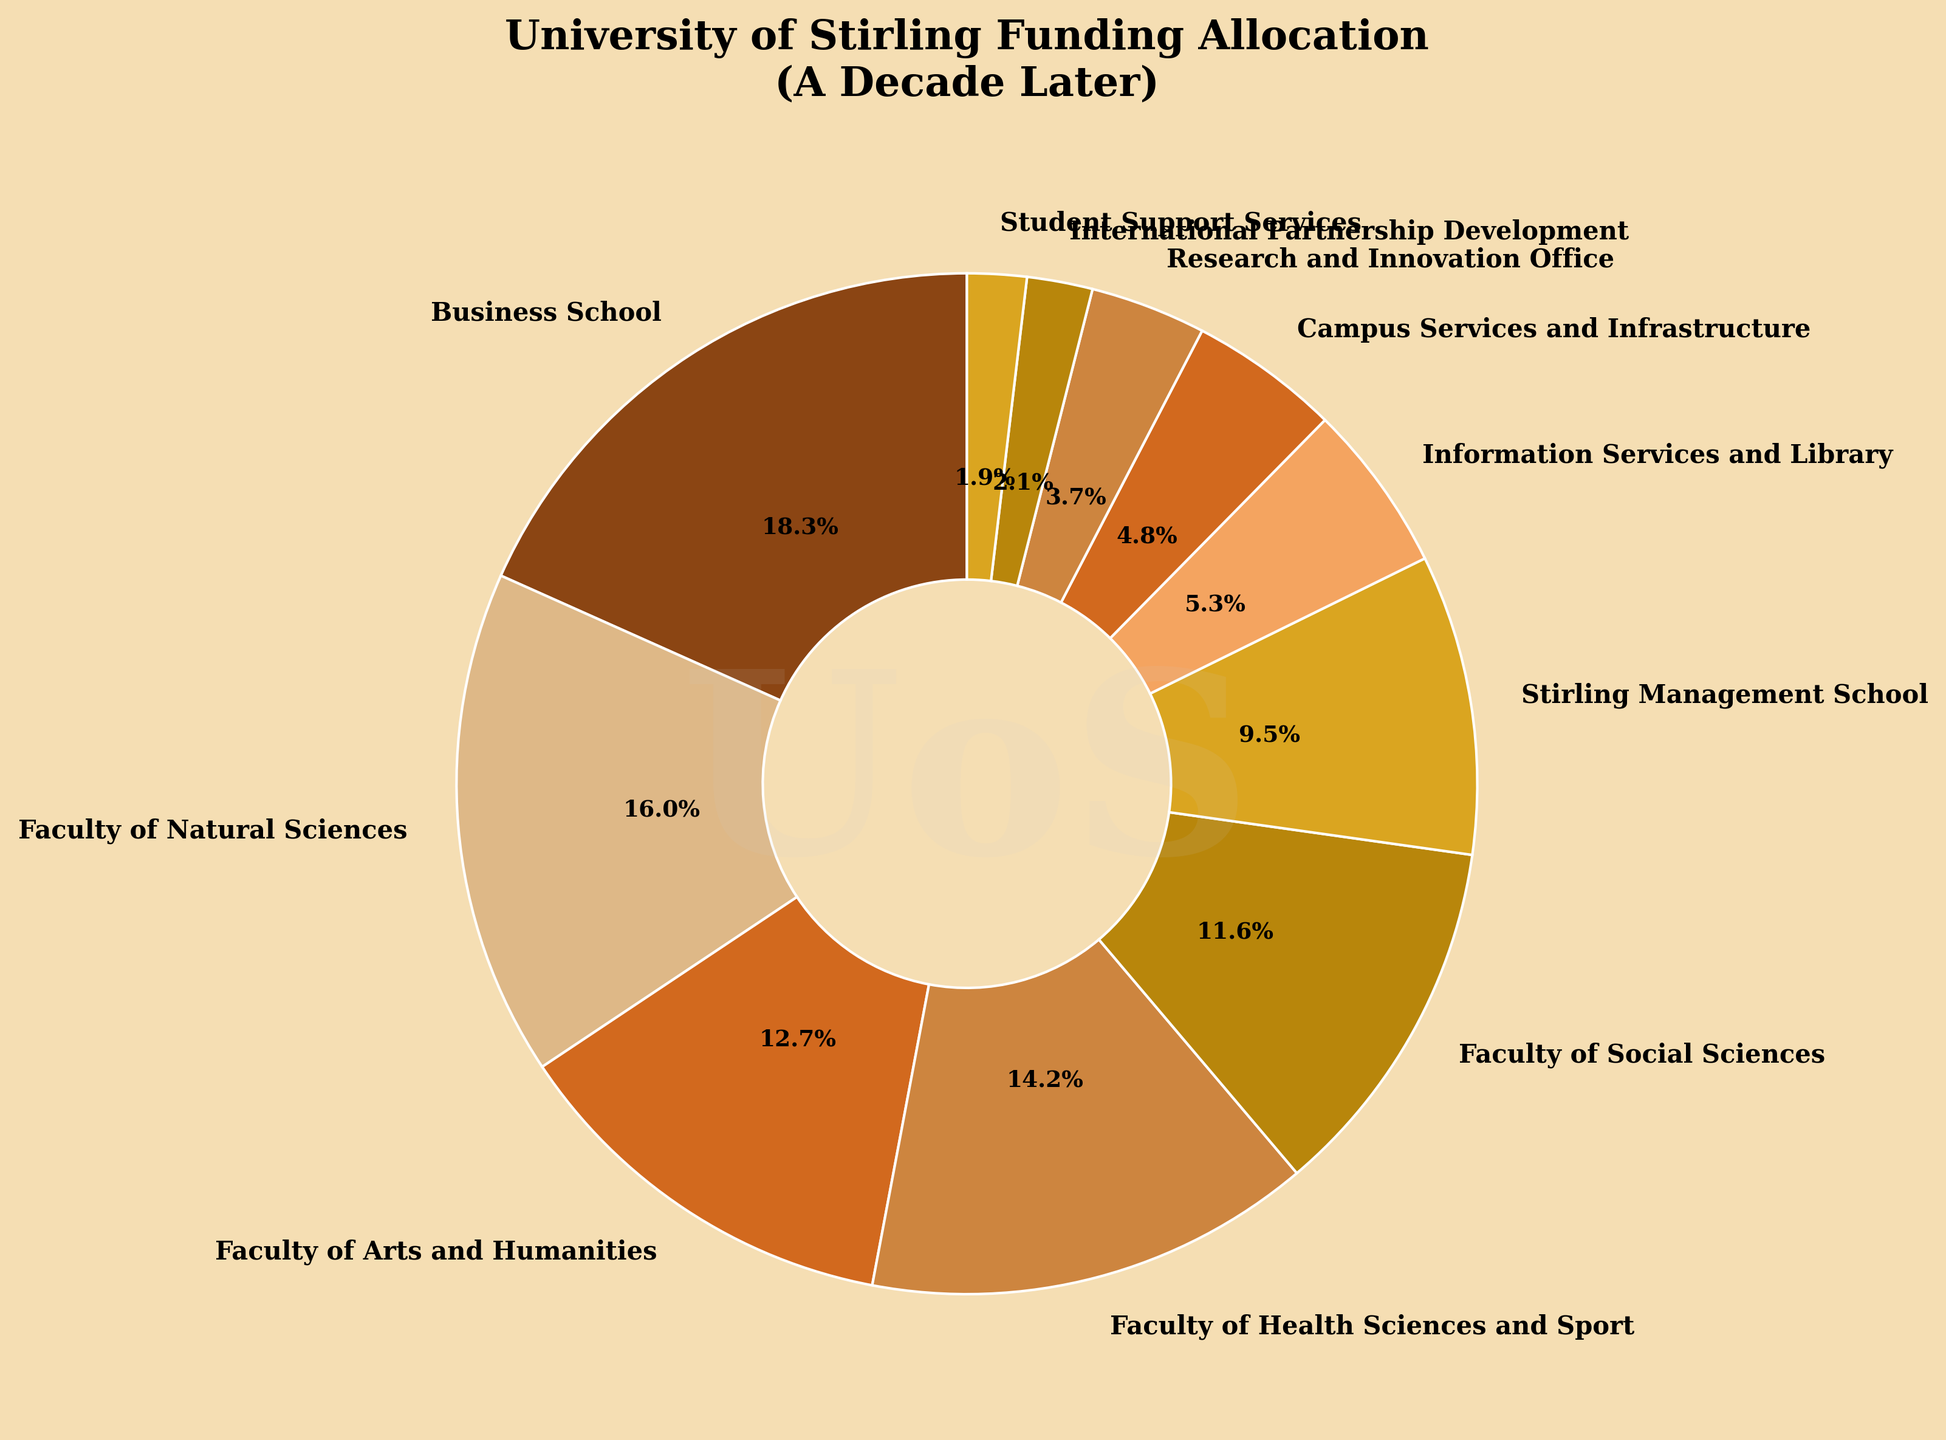Which department received the highest funding allocation? Identify the department with the largest percentage slice in the pie chart. The Business School slice is the largest at 18.5%.
Answer: Business School What is the combined funding allocation for the Faculty of Natural Sciences and the Faculty of Arts and Humanities? Add the percentages for the Faculty of Natural Sciences (16.2%) and the Faculty of Arts and Humanities (12.8%). The combined allocation is 16.2% + 12.8% = 29.0%.
Answer: 29.0% Which department has a higher funding allocation, Faculty of Health Sciences and Sport or Faculty of Social Sciences? Compare the percentages of the Faculty of Health Sciences and Sport (14.3%) and the Faculty of Social Sciences (11.7%). The Faculty of Health Sciences and Sport has a higher funding allocation.
Answer: Faculty of Health Sciences and Sport What is the total funding allocation for the Stirling Management School and Information Services and Library? Sum the percentages of the Stirling Management School (9.6%) and Information Services and Library (5.4%). The total allocation is 9.6% + 5.4% = 15.0%.
Answer: 15.0% Is the funding allocation for Campus Services and Infrastructure less than the Research and Innovation Office? Compare the percentages of Campus Services and Infrastructure (4.8%) and the Research and Innovation Office (3.7%). Campus Services and Infrastructure has a higher allocation than the Research and Innovation Office.
Answer: No Which department/facility has the smallest funding allocation? Identify the department/facility with the smallest percentage slice in the pie chart. Student Support Services has the smallest allocation at 1.9%.
Answer: Student Support Services How much more funding does the Business School receive compared to International Partnership Development? Subtract the percentage allocated to International Partnership Development (2.1%) from that allocated to the Business School (18.5%). The difference is 18.5% - 2.1% = 16.4%.
Answer: 16.4% What is the total funding allocation for all departments related to sciences (Faculty of Natural Sciences, Faculty of Health Sciences and Sport, Research and Innovation Office)? Add the percentages for the Faculty of Natural Sciences (16.2%), Faculty of Health Sciences and Sport (14.3%), and Research and Innovation Office (3.7%). The total allocation is 16.2% + 14.3% + 3.7% = 34.2%.
Answer: 34.2% Which slice has a combination of two shades of brown? Identify the colors used for the slices. The slices with the Faculty of Natural Sciences and the Faculty of Health Sciences and Sport are represented in shades of brown.
Answer: Faculty of Natural Sciences and Faculty of Health Sciences and Sport 